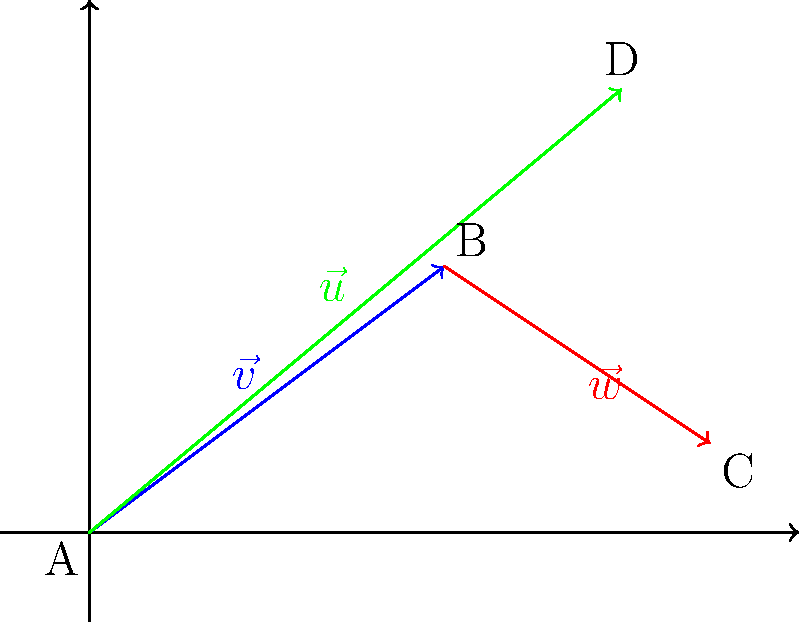As an environmentalist planning wildlife corridors, you're analyzing vector paths between three habitats. Given the vectors $\vec{v} = \langle 4, 3 \rangle$, $\vec{w} = \langle 3, -2 \rangle$, and $\vec{u} = \langle 6, 5 \rangle$ representing potential corridor routes, which path would provide the most direct connection between the starting point A and the endpoint C, while also passing close to an important water source at point D? To determine the optimal path, we need to compare the direct route from A to C with the route that passes through D. Let's break this down step-by-step:

1. Direct path from A to C:
   This is represented by $\vec{v} + \vec{w} = \langle 4, 3 \rangle + \langle 3, -2 \rangle = \langle 7, 1 \rangle$

2. Path from A to D:
   This is represented by $\vec{u} = \langle 6, 5 \rangle$

3. Path from D to C:
   We can calculate this by subtracting $\vec{u}$ from $\vec{v} + \vec{w}$:
   $(\vec{v} + \vec{w}) - \vec{u} = \langle 7, 1 \rangle - \langle 6, 5 \rangle = \langle 1, -4 \rangle$

4. Compare the magnitudes of the paths:
   a. Direct path: $\|\vec{v} + \vec{w}\| = \sqrt{7^2 + 1^2} = \sqrt{50} \approx 7.07$
   b. Path through D: $\|\vec{u}\| + \|(\vec{v} + \vec{w}) - \vec{u}\|$
      $= \sqrt{6^2 + 5^2} + \sqrt{1^2 + (-4)^2}$
      $= \sqrt{61} + \sqrt{17} \approx 7.81 + 4.12 = 11.93$

5. The direct path (A to C) is shorter, but doesn't pass by the water source at D.
   The path through D is longer but provides access to the water source.

6. Considering the importance of water sources for wildlife, the optimal path would be A to D to C, despite being longer. This route ensures access to the water source while still connecting the habitats.
Answer: A to D to C (path $\vec{u}$ followed by $(\vec{v} + \vec{w}) - \vec{u}$) 